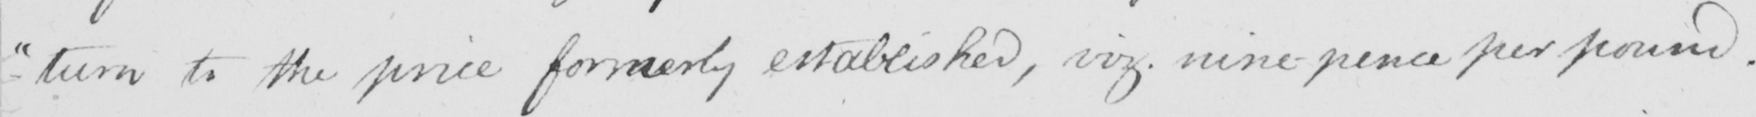Transcribe the text shown in this historical manuscript line. -turn to the price formerly established , viz . nine-pence per pound . 